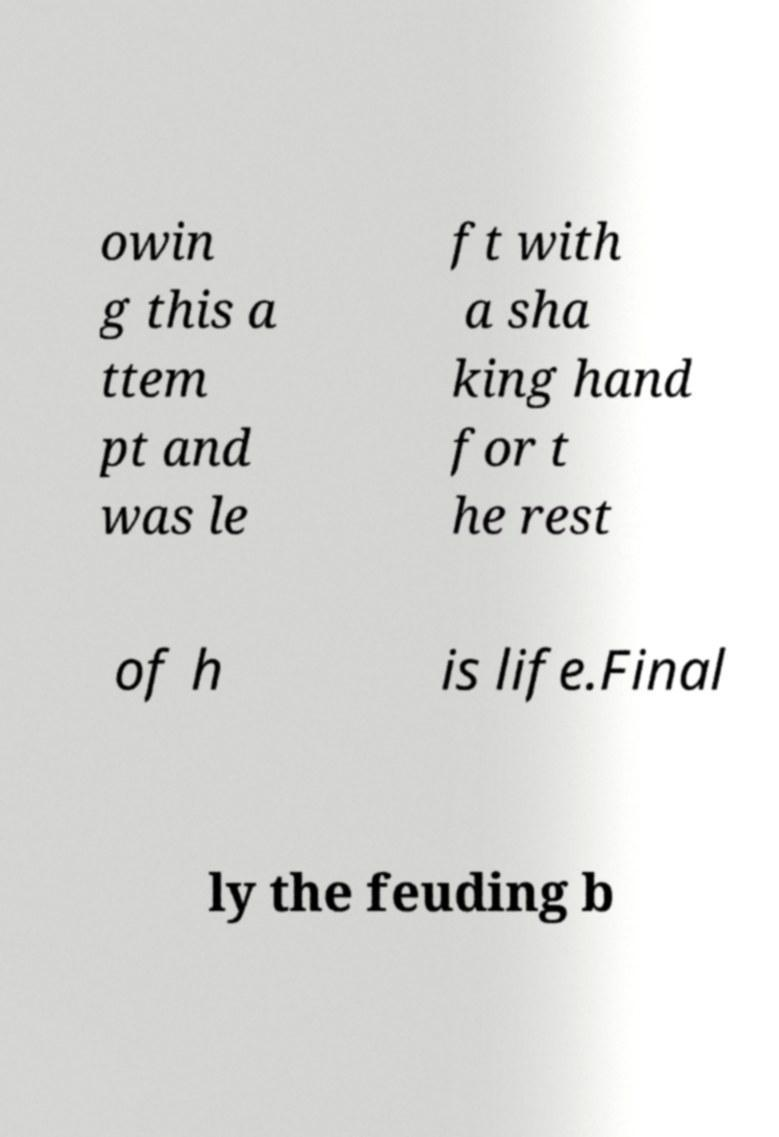Can you read and provide the text displayed in the image?This photo seems to have some interesting text. Can you extract and type it out for me? owin g this a ttem pt and was le ft with a sha king hand for t he rest of h is life.Final ly the feuding b 